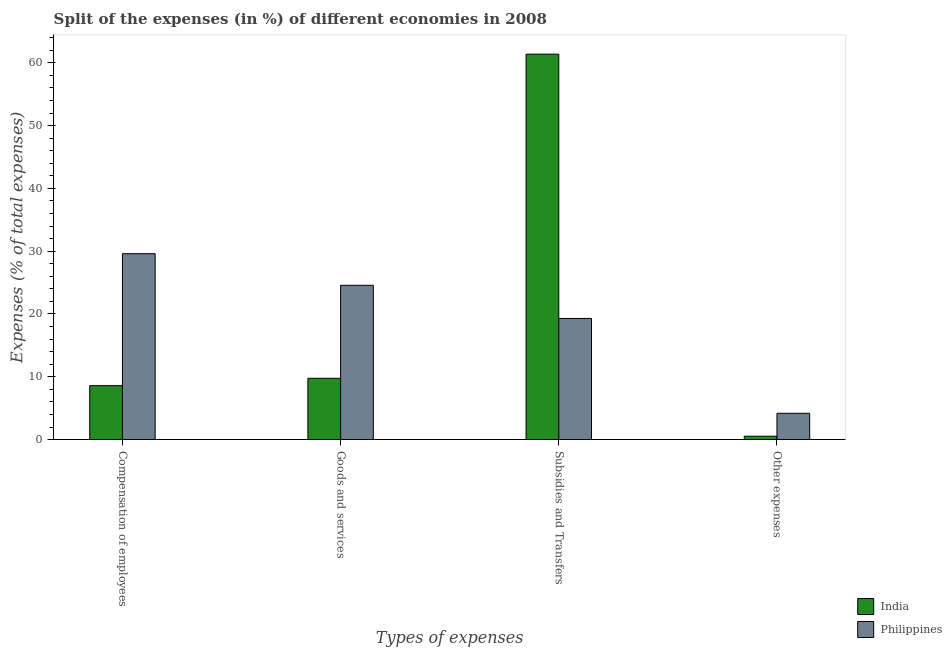How many groups of bars are there?
Provide a succinct answer. 4. How many bars are there on the 3rd tick from the right?
Offer a very short reply. 2. What is the label of the 2nd group of bars from the left?
Provide a succinct answer. Goods and services. What is the percentage of amount spent on subsidies in India?
Make the answer very short. 61.37. Across all countries, what is the maximum percentage of amount spent on goods and services?
Make the answer very short. 24.57. Across all countries, what is the minimum percentage of amount spent on other expenses?
Provide a succinct answer. 0.54. In which country was the percentage of amount spent on other expenses minimum?
Make the answer very short. India. What is the total percentage of amount spent on goods and services in the graph?
Keep it short and to the point. 34.33. What is the difference between the percentage of amount spent on compensation of employees in India and that in Philippines?
Make the answer very short. -21.02. What is the difference between the percentage of amount spent on other expenses in Philippines and the percentage of amount spent on subsidies in India?
Provide a short and direct response. -57.18. What is the average percentage of amount spent on compensation of employees per country?
Your answer should be very brief. 19.1. What is the difference between the percentage of amount spent on compensation of employees and percentage of amount spent on other expenses in India?
Give a very brief answer. 8.05. What is the ratio of the percentage of amount spent on subsidies in Philippines to that in India?
Make the answer very short. 0.31. Is the percentage of amount spent on subsidies in Philippines less than that in India?
Provide a short and direct response. Yes. Is the difference between the percentage of amount spent on compensation of employees in India and Philippines greater than the difference between the percentage of amount spent on goods and services in India and Philippines?
Give a very brief answer. No. What is the difference between the highest and the second highest percentage of amount spent on other expenses?
Keep it short and to the point. 3.65. What is the difference between the highest and the lowest percentage of amount spent on goods and services?
Make the answer very short. 14.8. Is the sum of the percentage of amount spent on subsidies in India and Philippines greater than the maximum percentage of amount spent on other expenses across all countries?
Provide a short and direct response. Yes. Is it the case that in every country, the sum of the percentage of amount spent on other expenses and percentage of amount spent on goods and services is greater than the sum of percentage of amount spent on compensation of employees and percentage of amount spent on subsidies?
Provide a short and direct response. No. What does the 1st bar from the right in Compensation of employees represents?
Keep it short and to the point. Philippines. Is it the case that in every country, the sum of the percentage of amount spent on compensation of employees and percentage of amount spent on goods and services is greater than the percentage of amount spent on subsidies?
Make the answer very short. No. How many countries are there in the graph?
Give a very brief answer. 2. What is the difference between two consecutive major ticks on the Y-axis?
Offer a very short reply. 10. Does the graph contain any zero values?
Your response must be concise. No. Where does the legend appear in the graph?
Your answer should be compact. Bottom right. How many legend labels are there?
Provide a succinct answer. 2. What is the title of the graph?
Your response must be concise. Split of the expenses (in %) of different economies in 2008. Does "Lithuania" appear as one of the legend labels in the graph?
Provide a short and direct response. No. What is the label or title of the X-axis?
Give a very brief answer. Types of expenses. What is the label or title of the Y-axis?
Provide a succinct answer. Expenses (% of total expenses). What is the Expenses (% of total expenses) in India in Compensation of employees?
Keep it short and to the point. 8.59. What is the Expenses (% of total expenses) of Philippines in Compensation of employees?
Make the answer very short. 29.6. What is the Expenses (% of total expenses) of India in Goods and services?
Provide a succinct answer. 9.76. What is the Expenses (% of total expenses) in Philippines in Goods and services?
Offer a very short reply. 24.57. What is the Expenses (% of total expenses) in India in Subsidies and Transfers?
Ensure brevity in your answer.  61.37. What is the Expenses (% of total expenses) in Philippines in Subsidies and Transfers?
Your answer should be very brief. 19.29. What is the Expenses (% of total expenses) in India in Other expenses?
Ensure brevity in your answer.  0.54. What is the Expenses (% of total expenses) of Philippines in Other expenses?
Provide a succinct answer. 4.19. Across all Types of expenses, what is the maximum Expenses (% of total expenses) of India?
Offer a very short reply. 61.37. Across all Types of expenses, what is the maximum Expenses (% of total expenses) of Philippines?
Offer a terse response. 29.6. Across all Types of expenses, what is the minimum Expenses (% of total expenses) of India?
Make the answer very short. 0.54. Across all Types of expenses, what is the minimum Expenses (% of total expenses) in Philippines?
Your answer should be compact. 4.19. What is the total Expenses (% of total expenses) of India in the graph?
Give a very brief answer. 80.27. What is the total Expenses (% of total expenses) of Philippines in the graph?
Ensure brevity in your answer.  77.65. What is the difference between the Expenses (% of total expenses) of India in Compensation of employees and that in Goods and services?
Make the answer very short. -1.17. What is the difference between the Expenses (% of total expenses) in Philippines in Compensation of employees and that in Goods and services?
Keep it short and to the point. 5.04. What is the difference between the Expenses (% of total expenses) of India in Compensation of employees and that in Subsidies and Transfers?
Keep it short and to the point. -52.78. What is the difference between the Expenses (% of total expenses) in Philippines in Compensation of employees and that in Subsidies and Transfers?
Provide a succinct answer. 10.32. What is the difference between the Expenses (% of total expenses) in India in Compensation of employees and that in Other expenses?
Keep it short and to the point. 8.05. What is the difference between the Expenses (% of total expenses) in Philippines in Compensation of employees and that in Other expenses?
Offer a terse response. 25.41. What is the difference between the Expenses (% of total expenses) in India in Goods and services and that in Subsidies and Transfers?
Your response must be concise. -51.61. What is the difference between the Expenses (% of total expenses) of Philippines in Goods and services and that in Subsidies and Transfers?
Your answer should be compact. 5.28. What is the difference between the Expenses (% of total expenses) in India in Goods and services and that in Other expenses?
Provide a succinct answer. 9.22. What is the difference between the Expenses (% of total expenses) in Philippines in Goods and services and that in Other expenses?
Keep it short and to the point. 20.38. What is the difference between the Expenses (% of total expenses) of India in Subsidies and Transfers and that in Other expenses?
Your response must be concise. 60.83. What is the difference between the Expenses (% of total expenses) in Philippines in Subsidies and Transfers and that in Other expenses?
Your answer should be compact. 15.1. What is the difference between the Expenses (% of total expenses) of India in Compensation of employees and the Expenses (% of total expenses) of Philippines in Goods and services?
Your answer should be compact. -15.98. What is the difference between the Expenses (% of total expenses) in India in Compensation of employees and the Expenses (% of total expenses) in Philippines in Subsidies and Transfers?
Keep it short and to the point. -10.7. What is the difference between the Expenses (% of total expenses) in India in Compensation of employees and the Expenses (% of total expenses) in Philippines in Other expenses?
Keep it short and to the point. 4.4. What is the difference between the Expenses (% of total expenses) in India in Goods and services and the Expenses (% of total expenses) in Philippines in Subsidies and Transfers?
Offer a terse response. -9.52. What is the difference between the Expenses (% of total expenses) of India in Goods and services and the Expenses (% of total expenses) of Philippines in Other expenses?
Your answer should be very brief. 5.57. What is the difference between the Expenses (% of total expenses) of India in Subsidies and Transfers and the Expenses (% of total expenses) of Philippines in Other expenses?
Your response must be concise. 57.18. What is the average Expenses (% of total expenses) in India per Types of expenses?
Your answer should be compact. 20.07. What is the average Expenses (% of total expenses) of Philippines per Types of expenses?
Give a very brief answer. 19.41. What is the difference between the Expenses (% of total expenses) in India and Expenses (% of total expenses) in Philippines in Compensation of employees?
Provide a short and direct response. -21.02. What is the difference between the Expenses (% of total expenses) in India and Expenses (% of total expenses) in Philippines in Goods and services?
Give a very brief answer. -14.8. What is the difference between the Expenses (% of total expenses) of India and Expenses (% of total expenses) of Philippines in Subsidies and Transfers?
Give a very brief answer. 42.09. What is the difference between the Expenses (% of total expenses) of India and Expenses (% of total expenses) of Philippines in Other expenses?
Give a very brief answer. -3.65. What is the ratio of the Expenses (% of total expenses) in India in Compensation of employees to that in Goods and services?
Offer a very short reply. 0.88. What is the ratio of the Expenses (% of total expenses) of Philippines in Compensation of employees to that in Goods and services?
Provide a short and direct response. 1.21. What is the ratio of the Expenses (% of total expenses) of India in Compensation of employees to that in Subsidies and Transfers?
Your answer should be compact. 0.14. What is the ratio of the Expenses (% of total expenses) in Philippines in Compensation of employees to that in Subsidies and Transfers?
Offer a very short reply. 1.53. What is the ratio of the Expenses (% of total expenses) in India in Compensation of employees to that in Other expenses?
Ensure brevity in your answer.  15.9. What is the ratio of the Expenses (% of total expenses) in Philippines in Compensation of employees to that in Other expenses?
Provide a short and direct response. 7.06. What is the ratio of the Expenses (% of total expenses) of India in Goods and services to that in Subsidies and Transfers?
Your response must be concise. 0.16. What is the ratio of the Expenses (% of total expenses) of Philippines in Goods and services to that in Subsidies and Transfers?
Give a very brief answer. 1.27. What is the ratio of the Expenses (% of total expenses) in India in Goods and services to that in Other expenses?
Your response must be concise. 18.08. What is the ratio of the Expenses (% of total expenses) of Philippines in Goods and services to that in Other expenses?
Offer a very short reply. 5.86. What is the ratio of the Expenses (% of total expenses) of India in Subsidies and Transfers to that in Other expenses?
Make the answer very short. 113.63. What is the ratio of the Expenses (% of total expenses) in Philippines in Subsidies and Transfers to that in Other expenses?
Ensure brevity in your answer.  4.6. What is the difference between the highest and the second highest Expenses (% of total expenses) in India?
Provide a short and direct response. 51.61. What is the difference between the highest and the second highest Expenses (% of total expenses) in Philippines?
Make the answer very short. 5.04. What is the difference between the highest and the lowest Expenses (% of total expenses) of India?
Your answer should be very brief. 60.83. What is the difference between the highest and the lowest Expenses (% of total expenses) of Philippines?
Offer a terse response. 25.41. 